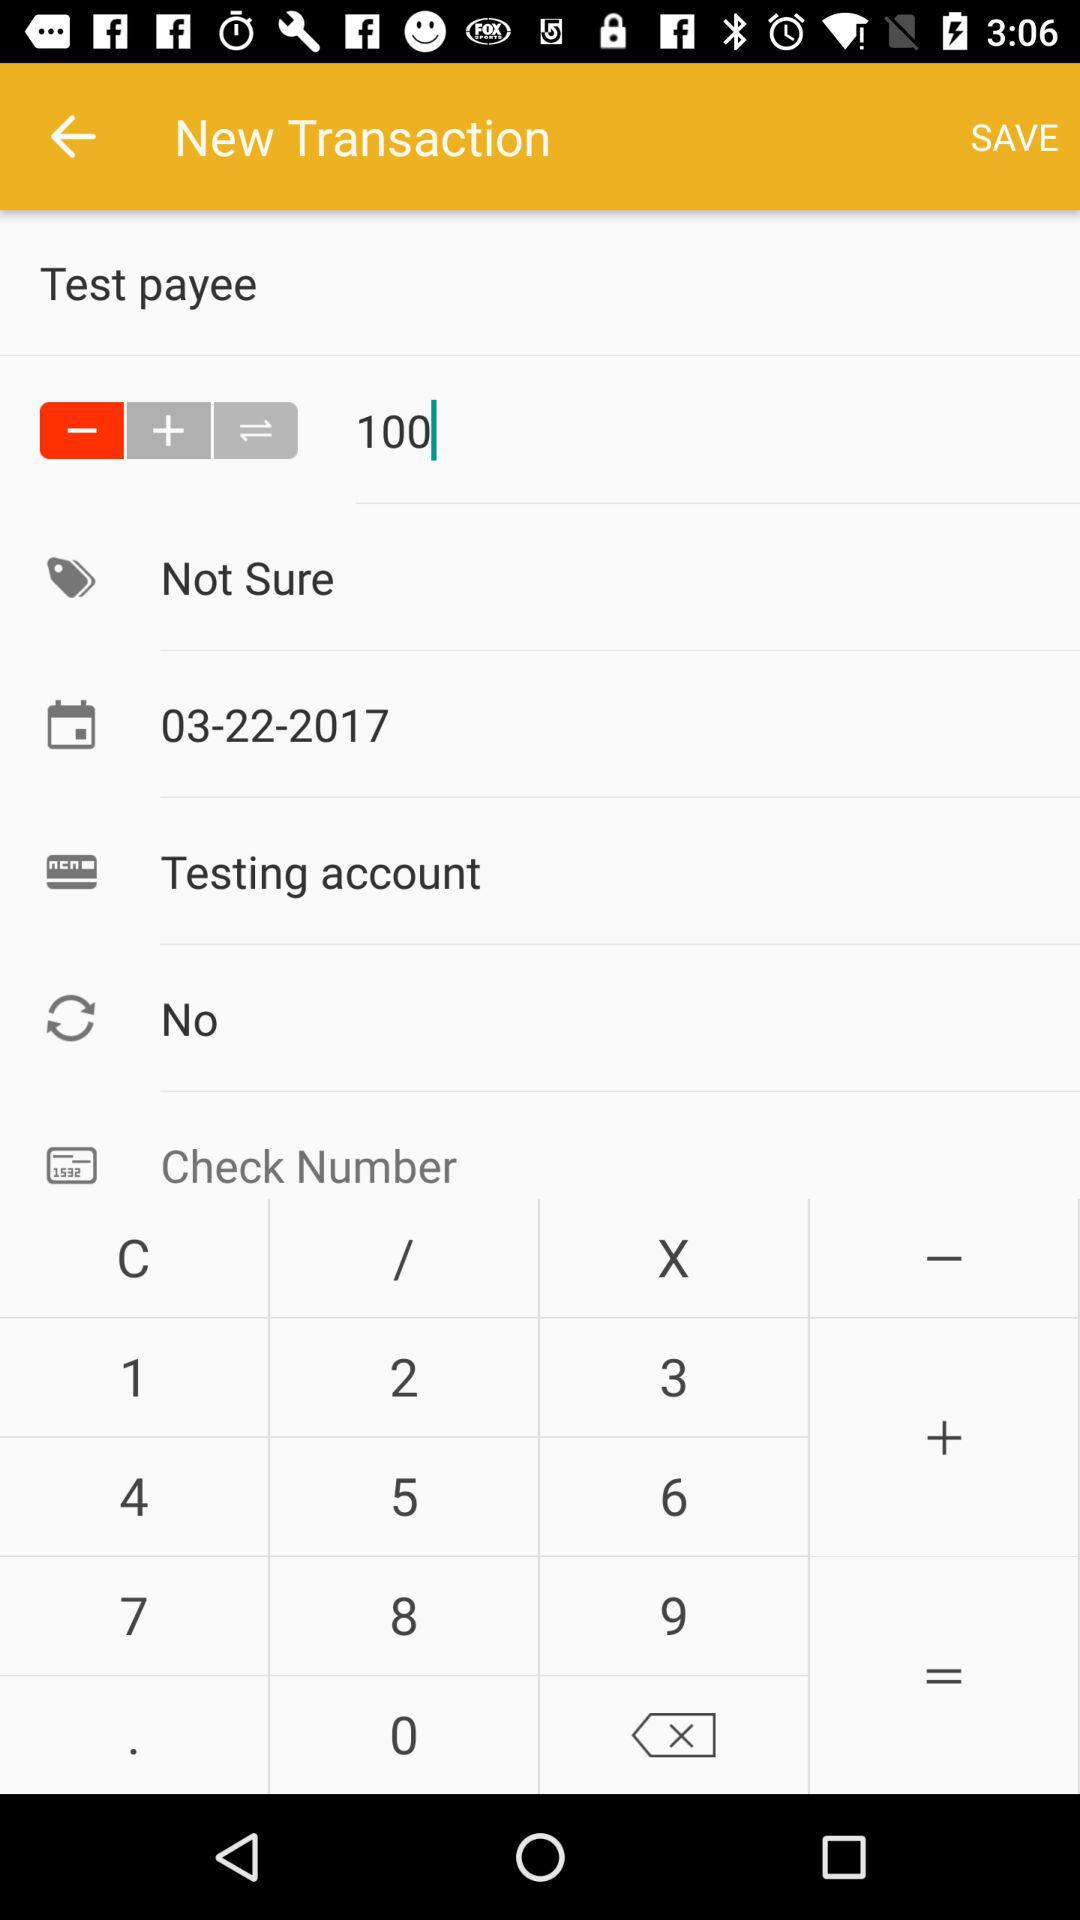What is the date of the transaction?
Answer the question using a single word or phrase. 03-22-2017 